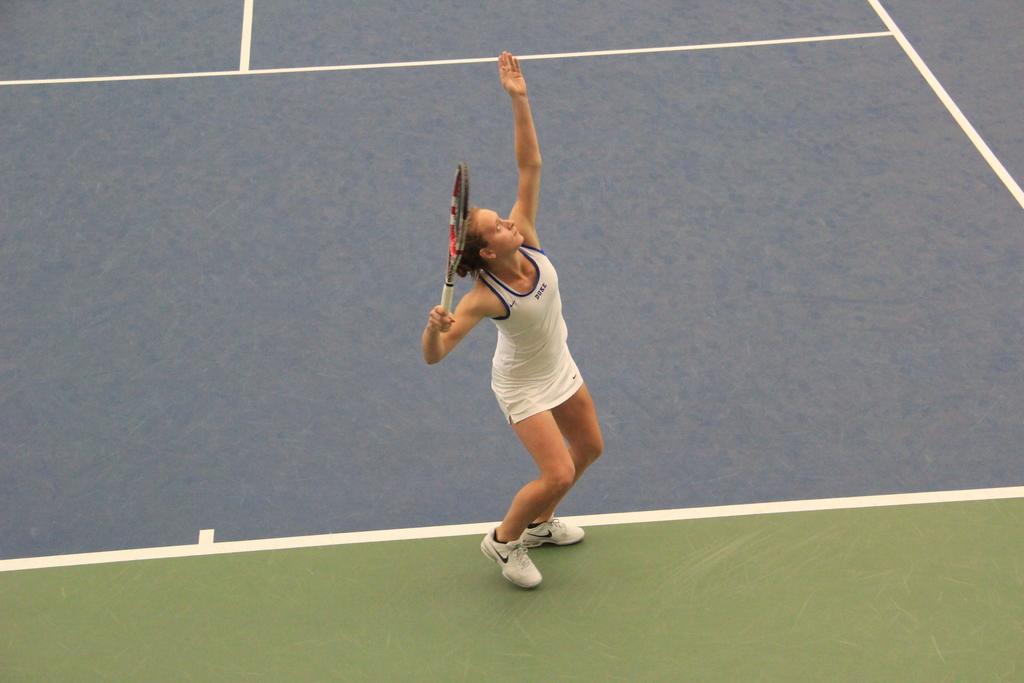Describe this image in one or two sentences. This picture is taken in the tennis ground, In the middle there is a woman standing and she is holding a bat in the background there is a floor which is in gray color. 